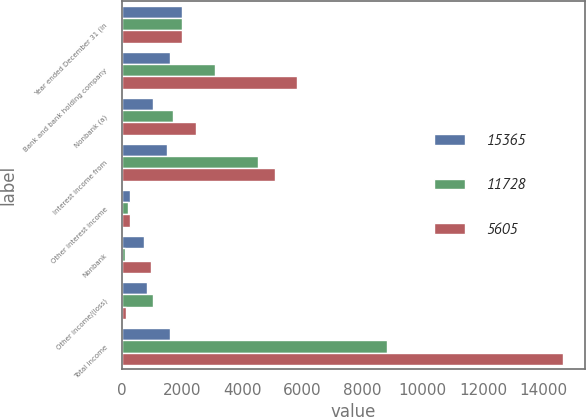Convert chart. <chart><loc_0><loc_0><loc_500><loc_500><stacked_bar_chart><ecel><fcel>Year ended December 31 (in<fcel>Bank and bank holding company<fcel>Nonbank (a)<fcel>Interest income from<fcel>Other interest income<fcel>Nonbank<fcel>Other income/(loss)<fcel>Total income<nl><fcel>15365<fcel>2009<fcel>1594<fcel>1036<fcel>1501<fcel>266<fcel>742<fcel>844<fcel>1594<nl><fcel>11728<fcel>2008<fcel>3085<fcel>1687<fcel>4539<fcel>212<fcel>95<fcel>1038<fcel>8824<nl><fcel>5605<fcel>2007<fcel>5834<fcel>2463<fcel>5082<fcel>263<fcel>960<fcel>131<fcel>14653<nl></chart> 